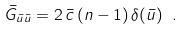<formula> <loc_0><loc_0><loc_500><loc_500>\bar { G } _ { \bar { u } \bar { u } } = 2 \, \bar { c } \, ( n - 1 ) \, \delta ( \bar { u } ) \ .</formula> 